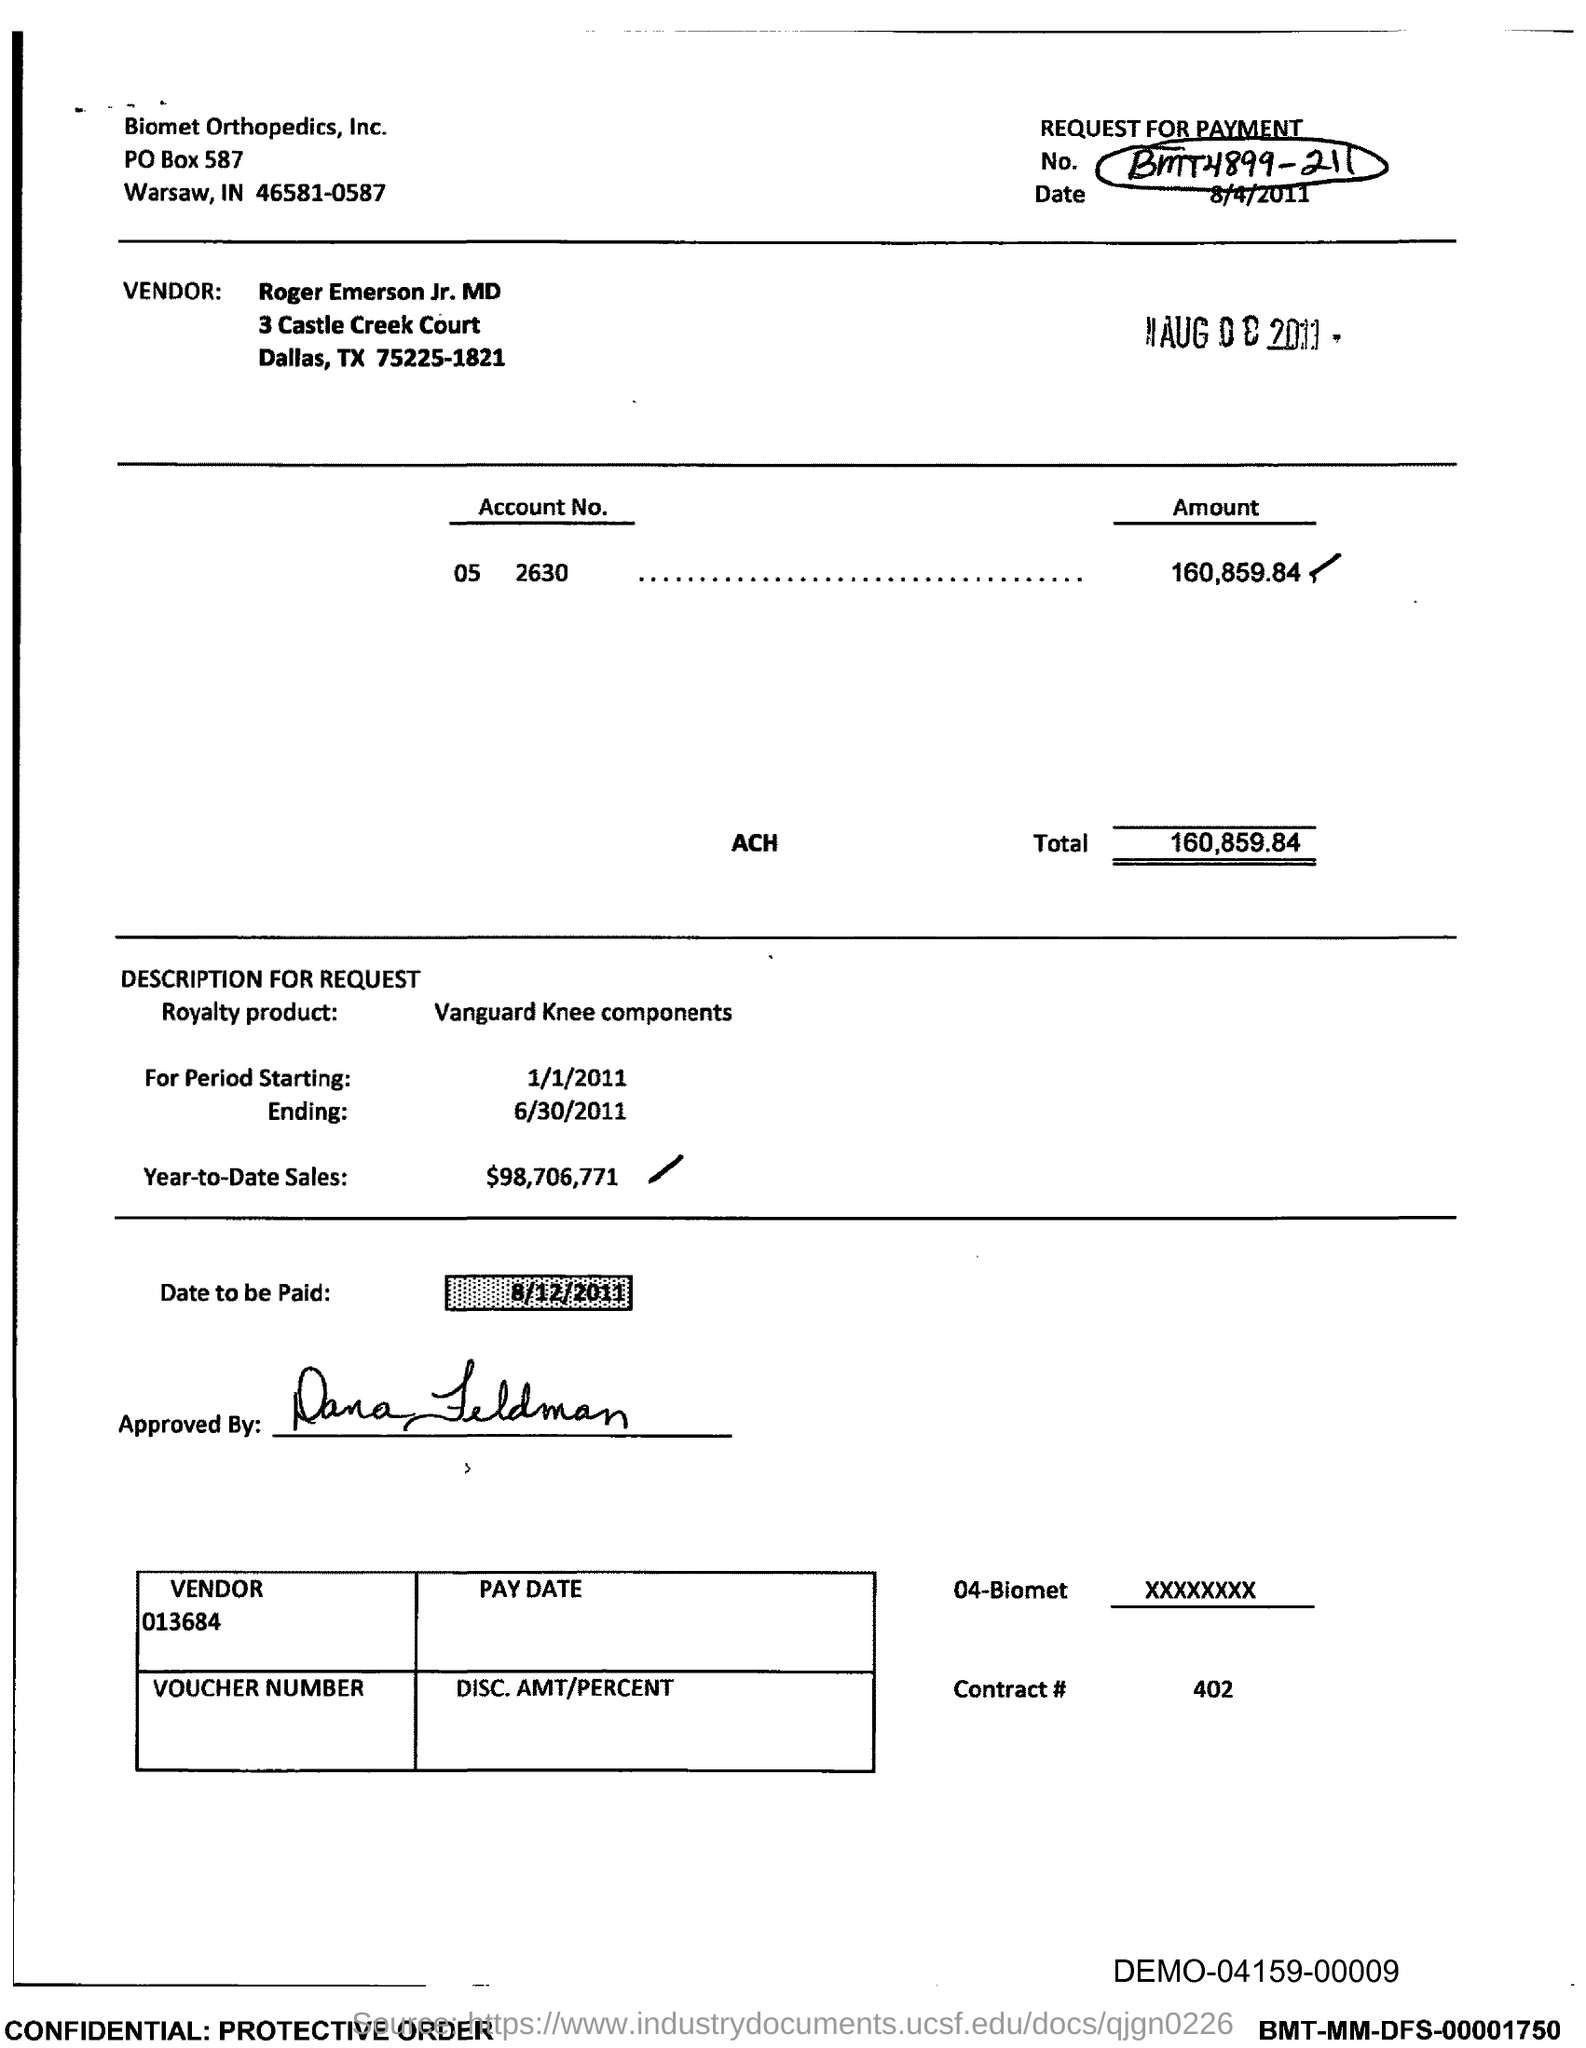Outline some significant characteristics in this image. The year-to-date sales as of today are $98,706,771. The total is 160,859.84 dollars. 